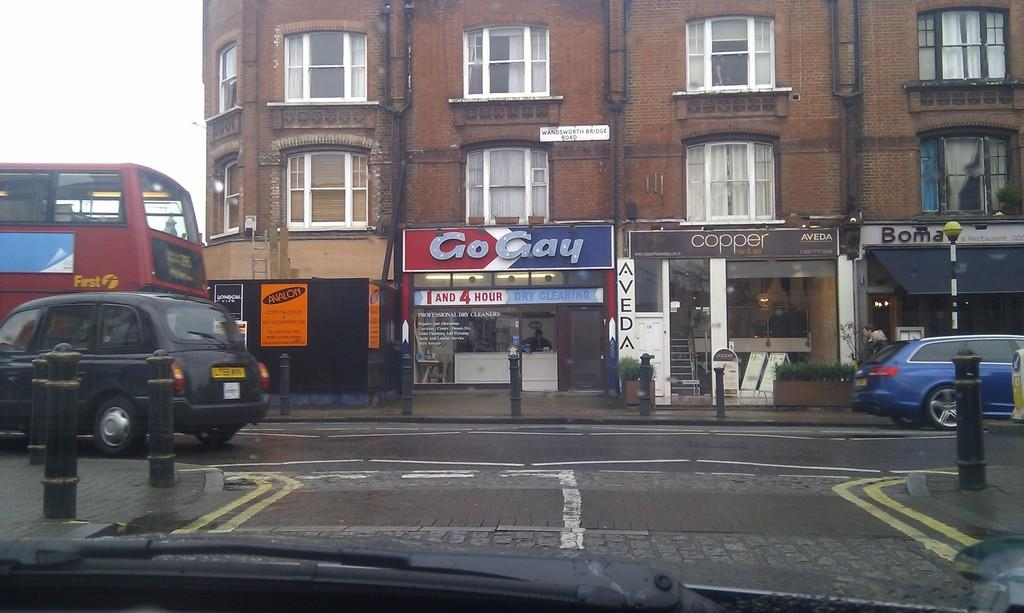<image>
Offer a succinct explanation of the picture presented. The dry cleaning shop on this street is called Go Gay. 